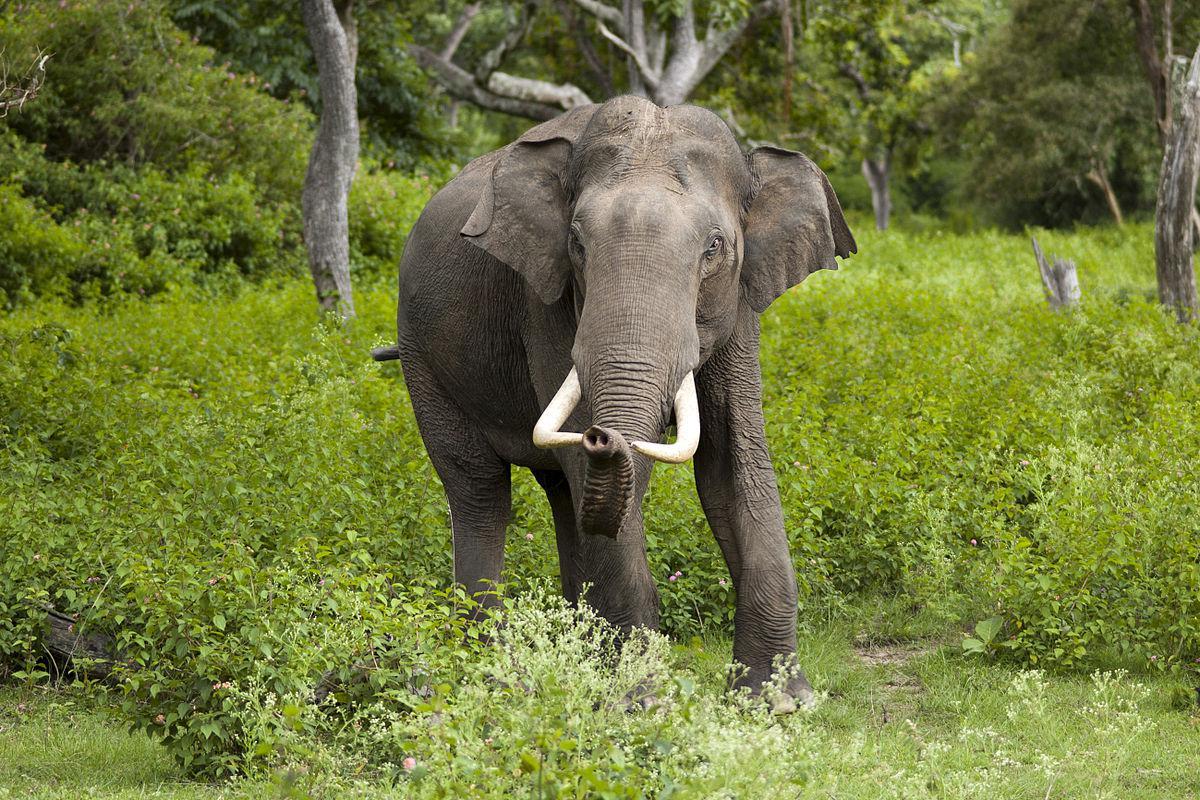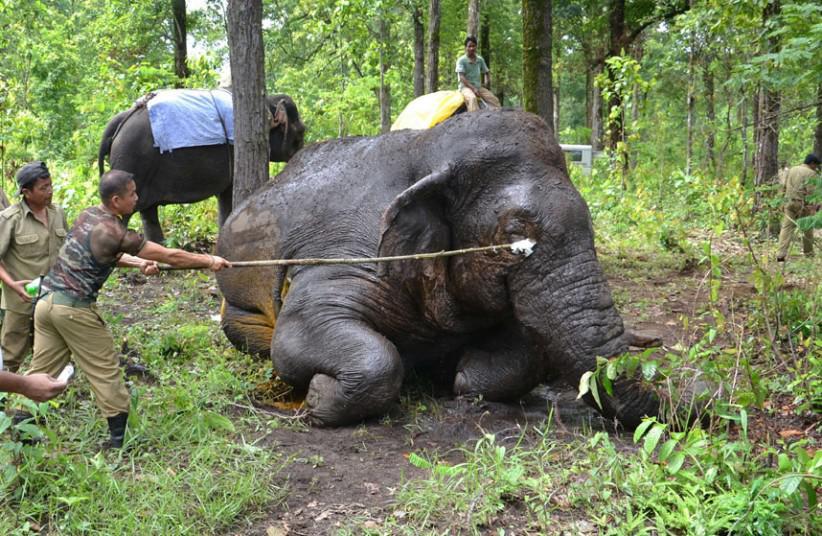The first image is the image on the left, the second image is the image on the right. Considering the images on both sides, is "An image shows a camera-facing elephant with tusks and trunk pointed downward." valid? Answer yes or no. No. 